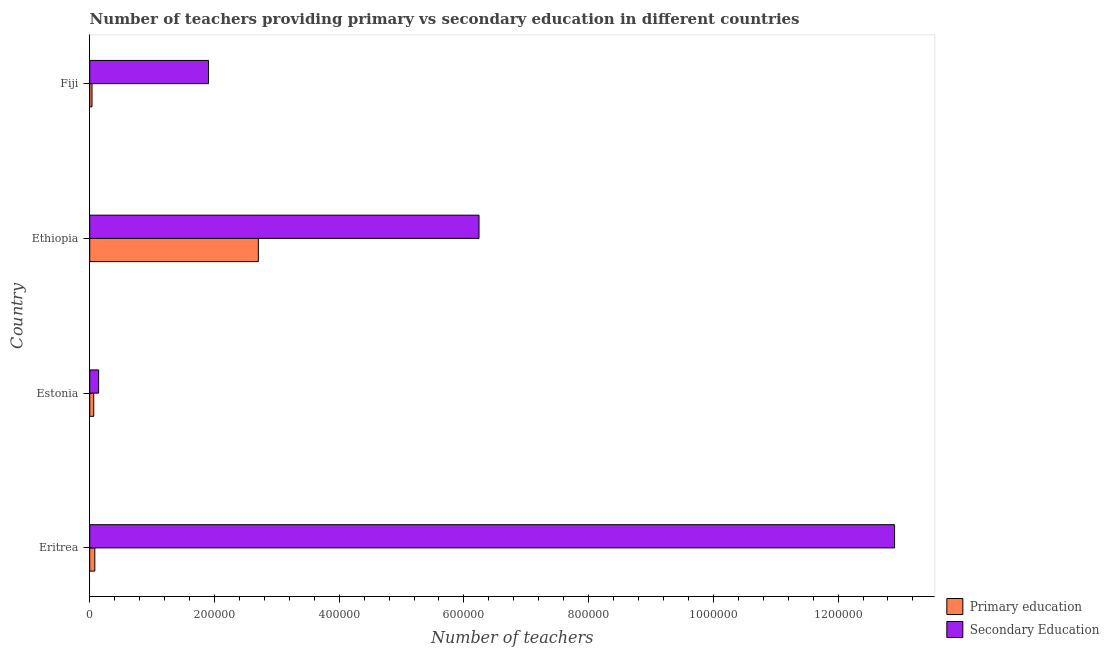How many different coloured bars are there?
Provide a succinct answer. 2. Are the number of bars on each tick of the Y-axis equal?
Provide a short and direct response. Yes. How many bars are there on the 1st tick from the top?
Your response must be concise. 2. What is the label of the 3rd group of bars from the top?
Your answer should be very brief. Estonia. What is the number of primary teachers in Eritrea?
Keep it short and to the point. 8166. Across all countries, what is the maximum number of secondary teachers?
Offer a terse response. 1.29e+06. Across all countries, what is the minimum number of secondary teachers?
Give a very brief answer. 1.43e+04. In which country was the number of primary teachers maximum?
Give a very brief answer. Ethiopia. In which country was the number of primary teachers minimum?
Provide a short and direct response. Fiji. What is the total number of secondary teachers in the graph?
Your answer should be compact. 2.12e+06. What is the difference between the number of primary teachers in Estonia and that in Ethiopia?
Provide a short and direct response. -2.64e+05. What is the difference between the number of secondary teachers in Estonia and the number of primary teachers in Eritrea?
Your response must be concise. 6090. What is the average number of secondary teachers per country?
Keep it short and to the point. 5.30e+05. What is the difference between the number of secondary teachers and number of primary teachers in Estonia?
Keep it short and to the point. 7825. What is the ratio of the number of secondary teachers in Eritrea to that in Fiji?
Give a very brief answer. 6.78. What is the difference between the highest and the second highest number of secondary teachers?
Your answer should be compact. 6.66e+05. What is the difference between the highest and the lowest number of primary teachers?
Ensure brevity in your answer.  2.67e+05. In how many countries, is the number of primary teachers greater than the average number of primary teachers taken over all countries?
Your response must be concise. 1. Is the sum of the number of secondary teachers in Estonia and Fiji greater than the maximum number of primary teachers across all countries?
Offer a very short reply. No. What does the 1st bar from the top in Fiji represents?
Keep it short and to the point. Secondary Education. What does the 1st bar from the bottom in Fiji represents?
Your response must be concise. Primary education. Are all the bars in the graph horizontal?
Ensure brevity in your answer.  Yes. How many countries are there in the graph?
Offer a terse response. 4. Are the values on the major ticks of X-axis written in scientific E-notation?
Offer a very short reply. No. Does the graph contain any zero values?
Give a very brief answer. No. Where does the legend appear in the graph?
Give a very brief answer. Bottom right. How are the legend labels stacked?
Offer a terse response. Vertical. What is the title of the graph?
Give a very brief answer. Number of teachers providing primary vs secondary education in different countries. What is the label or title of the X-axis?
Make the answer very short. Number of teachers. What is the label or title of the Y-axis?
Offer a very short reply. Country. What is the Number of teachers in Primary education in Eritrea?
Make the answer very short. 8166. What is the Number of teachers of Secondary Education in Eritrea?
Give a very brief answer. 1.29e+06. What is the Number of teachers in Primary education in Estonia?
Your response must be concise. 6431. What is the Number of teachers of Secondary Education in Estonia?
Ensure brevity in your answer.  1.43e+04. What is the Number of teachers of Primary education in Ethiopia?
Give a very brief answer. 2.70e+05. What is the Number of teachers of Secondary Education in Ethiopia?
Offer a very short reply. 6.24e+05. What is the Number of teachers of Primary education in Fiji?
Your response must be concise. 3671. What is the Number of teachers in Secondary Education in Fiji?
Provide a short and direct response. 1.90e+05. Across all countries, what is the maximum Number of teachers in Primary education?
Offer a terse response. 2.70e+05. Across all countries, what is the maximum Number of teachers in Secondary Education?
Your answer should be compact. 1.29e+06. Across all countries, what is the minimum Number of teachers in Primary education?
Offer a very short reply. 3671. Across all countries, what is the minimum Number of teachers of Secondary Education?
Offer a terse response. 1.43e+04. What is the total Number of teachers of Primary education in the graph?
Offer a terse response. 2.89e+05. What is the total Number of teachers of Secondary Education in the graph?
Make the answer very short. 2.12e+06. What is the difference between the Number of teachers in Primary education in Eritrea and that in Estonia?
Give a very brief answer. 1735. What is the difference between the Number of teachers in Secondary Education in Eritrea and that in Estonia?
Your response must be concise. 1.28e+06. What is the difference between the Number of teachers of Primary education in Eritrea and that in Ethiopia?
Offer a terse response. -2.62e+05. What is the difference between the Number of teachers of Secondary Education in Eritrea and that in Ethiopia?
Provide a succinct answer. 6.66e+05. What is the difference between the Number of teachers of Primary education in Eritrea and that in Fiji?
Your answer should be compact. 4495. What is the difference between the Number of teachers of Secondary Education in Eritrea and that in Fiji?
Keep it short and to the point. 1.10e+06. What is the difference between the Number of teachers in Primary education in Estonia and that in Ethiopia?
Your response must be concise. -2.64e+05. What is the difference between the Number of teachers in Secondary Education in Estonia and that in Ethiopia?
Ensure brevity in your answer.  -6.10e+05. What is the difference between the Number of teachers of Primary education in Estonia and that in Fiji?
Your response must be concise. 2760. What is the difference between the Number of teachers of Secondary Education in Estonia and that in Fiji?
Keep it short and to the point. -1.76e+05. What is the difference between the Number of teachers of Primary education in Ethiopia and that in Fiji?
Offer a terse response. 2.67e+05. What is the difference between the Number of teachers in Secondary Education in Ethiopia and that in Fiji?
Give a very brief answer. 4.34e+05. What is the difference between the Number of teachers in Primary education in Eritrea and the Number of teachers in Secondary Education in Estonia?
Provide a short and direct response. -6090. What is the difference between the Number of teachers of Primary education in Eritrea and the Number of teachers of Secondary Education in Ethiopia?
Offer a very short reply. -6.16e+05. What is the difference between the Number of teachers in Primary education in Eritrea and the Number of teachers in Secondary Education in Fiji?
Keep it short and to the point. -1.82e+05. What is the difference between the Number of teachers in Primary education in Estonia and the Number of teachers in Secondary Education in Ethiopia?
Your answer should be very brief. -6.18e+05. What is the difference between the Number of teachers of Primary education in Estonia and the Number of teachers of Secondary Education in Fiji?
Give a very brief answer. -1.84e+05. What is the difference between the Number of teachers of Primary education in Ethiopia and the Number of teachers of Secondary Education in Fiji?
Your answer should be very brief. 7.99e+04. What is the average Number of teachers in Primary education per country?
Your response must be concise. 7.22e+04. What is the average Number of teachers of Secondary Education per country?
Provide a short and direct response. 5.30e+05. What is the difference between the Number of teachers of Primary education and Number of teachers of Secondary Education in Eritrea?
Your response must be concise. -1.28e+06. What is the difference between the Number of teachers of Primary education and Number of teachers of Secondary Education in Estonia?
Keep it short and to the point. -7825. What is the difference between the Number of teachers of Primary education and Number of teachers of Secondary Education in Ethiopia?
Make the answer very short. -3.54e+05. What is the difference between the Number of teachers of Primary education and Number of teachers of Secondary Education in Fiji?
Keep it short and to the point. -1.87e+05. What is the ratio of the Number of teachers in Primary education in Eritrea to that in Estonia?
Provide a succinct answer. 1.27. What is the ratio of the Number of teachers of Secondary Education in Eritrea to that in Estonia?
Your response must be concise. 90.53. What is the ratio of the Number of teachers in Primary education in Eritrea to that in Ethiopia?
Make the answer very short. 0.03. What is the ratio of the Number of teachers of Secondary Education in Eritrea to that in Ethiopia?
Make the answer very short. 2.07. What is the ratio of the Number of teachers of Primary education in Eritrea to that in Fiji?
Offer a very short reply. 2.22. What is the ratio of the Number of teachers of Secondary Education in Eritrea to that in Fiji?
Give a very brief answer. 6.78. What is the ratio of the Number of teachers of Primary education in Estonia to that in Ethiopia?
Your response must be concise. 0.02. What is the ratio of the Number of teachers of Secondary Education in Estonia to that in Ethiopia?
Give a very brief answer. 0.02. What is the ratio of the Number of teachers of Primary education in Estonia to that in Fiji?
Your response must be concise. 1.75. What is the ratio of the Number of teachers of Secondary Education in Estonia to that in Fiji?
Your answer should be very brief. 0.07. What is the ratio of the Number of teachers of Primary education in Ethiopia to that in Fiji?
Your response must be concise. 73.65. What is the ratio of the Number of teachers in Secondary Education in Ethiopia to that in Fiji?
Ensure brevity in your answer.  3.28. What is the difference between the highest and the second highest Number of teachers of Primary education?
Offer a very short reply. 2.62e+05. What is the difference between the highest and the second highest Number of teachers in Secondary Education?
Provide a short and direct response. 6.66e+05. What is the difference between the highest and the lowest Number of teachers of Primary education?
Provide a short and direct response. 2.67e+05. What is the difference between the highest and the lowest Number of teachers of Secondary Education?
Give a very brief answer. 1.28e+06. 